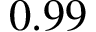Convert formula to latex. <formula><loc_0><loc_0><loc_500><loc_500>0 . 9 9</formula> 